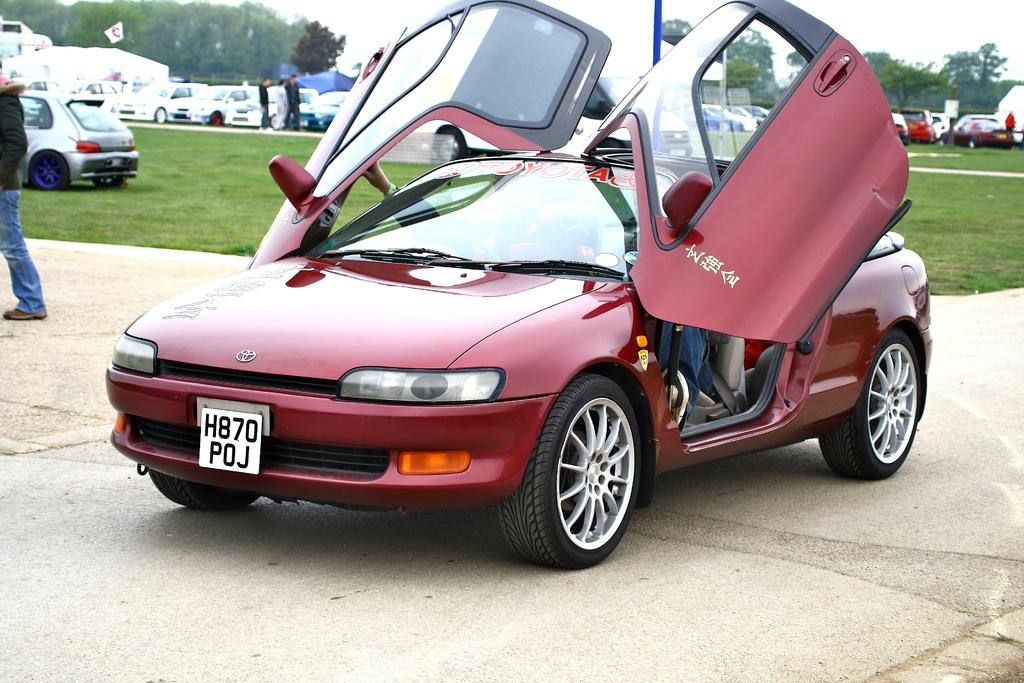What is the main subject of the image? There is a vehicle in the image. What is the state of the vehicle doors? The vehicle doors are open. What can be seen in the background of the image? There is grass, other vehicles, people, a pole, a board, trees, and the sky visible in the background of the image. What type of camp can be seen in the image? There is no camp present in the image. How many weeks have passed since the events in the image took place? The image does not provide any information about the passage of time, so it is impossible to determine how many weeks have passed. 